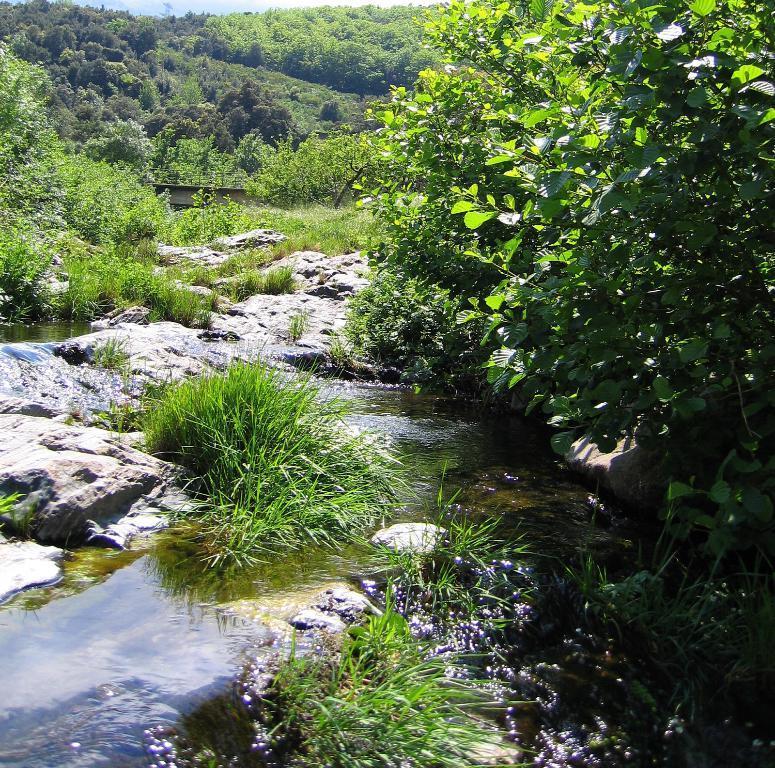Please provide a concise description of this image. There is water, rocks, plants and trees. 